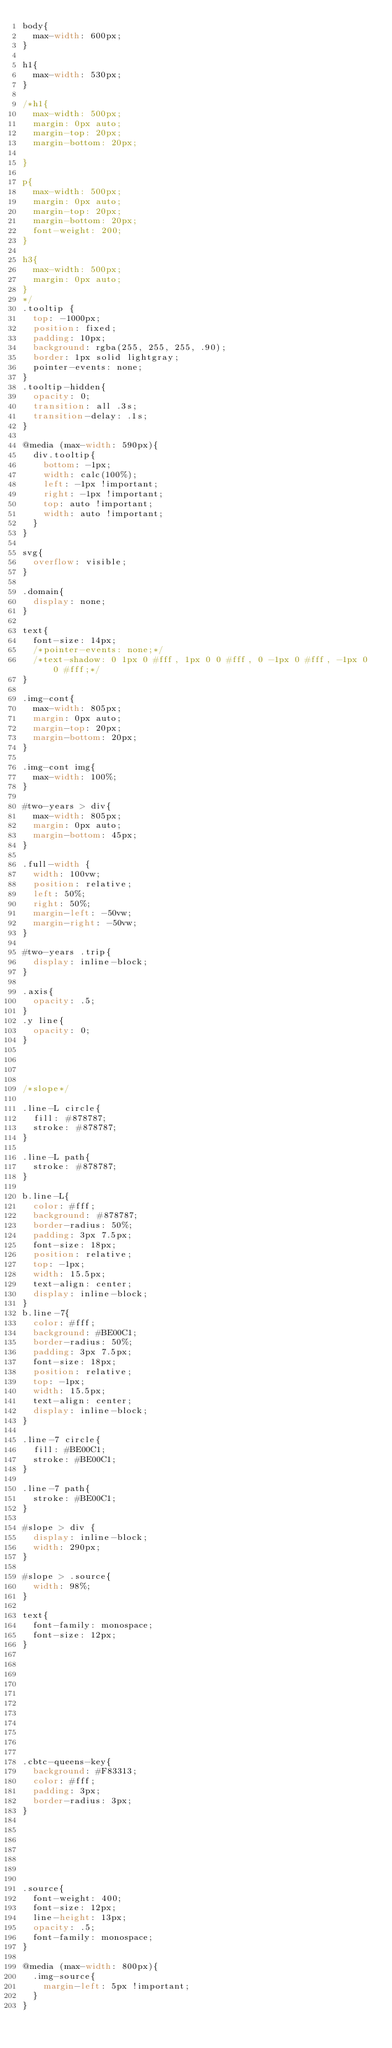Convert code to text. <code><loc_0><loc_0><loc_500><loc_500><_CSS_>body{
  max-width: 600px;
}

h1{
  max-width: 530px;
}

/*h1{
  max-width: 500px;
  margin: 0px auto;
  margin-top: 20px;
  margin-bottom: 20px;

}

p{
  max-width: 500px;
  margin: 0px auto;
  margin-top: 20px;
  margin-bottom: 20px;
  font-weight: 200;
}

h3{
  max-width: 500px;
  margin: 0px auto;
}
*/
.tooltip {
  top: -1000px;
  position: fixed;
  padding: 10px;
  background: rgba(255, 255, 255, .90);
  border: 1px solid lightgray;
  pointer-events: none;
}
.tooltip-hidden{
  opacity: 0;
  transition: all .3s;
  transition-delay: .1s;
}

@media (max-width: 590px){
  div.tooltip{
    bottom: -1px;
    width: calc(100%);
    left: -1px !important;
    right: -1px !important;
    top: auto !important;
    width: auto !important;
  }
}

svg{
  overflow: visible;
}

.domain{
  display: none;
}

text{
  font-size: 14px;
  /*pointer-events: none;*/
  /*text-shadow: 0 1px 0 #fff, 1px 0 0 #fff, 0 -1px 0 #fff, -1px 0 0 #fff;*/
}

.img-cont{
  max-width: 805px;
  margin: 0px auto;
  margin-top: 20px;
  margin-bottom: 20px;
}

.img-cont img{
  max-width: 100%;
}

#two-years > div{
  max-width: 805px;
  margin: 0px auto;
  margin-bottom: 45px;
}

.full-width {
  width: 100vw;
  position: relative;
  left: 50%;
  right: 50%;
  margin-left: -50vw;
  margin-right: -50vw;
}

#two-years .trip{
  display: inline-block;
}

.axis{
  opacity: .5;
}
.y line{
  opacity: 0;
}




/*slope*/

.line-L circle{
  fill: #878787;
  stroke: #878787;
}

.line-L path{
  stroke: #878787;
}

b.line-L{
  color: #fff;
  background: #878787;
  border-radius: 50%;
  padding: 3px 7.5px;
  font-size: 18px;
  position: relative;
  top: -1px;
  width: 15.5px;
  text-align: center;
  display: inline-block;
}
b.line-7{
  color: #fff;
  background: #BE00C1;
  border-radius: 50%;
  padding: 3px 7.5px;
  font-size: 18px;
  position: relative;
  top: -1px;
  width: 15.5px;
  text-align: center;
  display: inline-block;
}

.line-7 circle{
  fill: #BE00C1;
  stroke: #BE00C1;
}

.line-7 path{
  stroke: #BE00C1;
}

#slope > div {
  display: inline-block;
  width: 290px;
}

#slope > .source{
  width: 98%;
}

text{
  font-family: monospace;
  font-size: 12px;
}











.cbtc-queens-key{
  background: #F83313;
  color: #fff;
  padding: 3px;
  border-radius: 3px;
}







.source{
  font-weight: 400;
  font-size: 12px;
  line-height: 13px;
  opacity: .5;
  font-family: monospace;
}

@media (max-width: 800px){
  .img-source{
    margin-left: 5px !important;
  }
}








</code> 